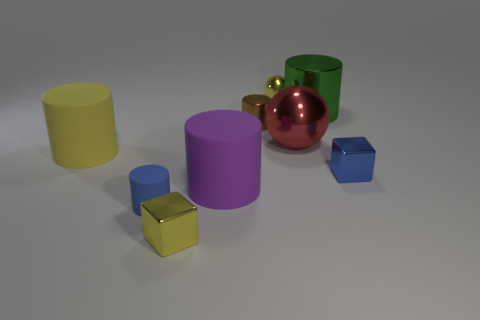Are any large green rubber cylinders visible?
Provide a succinct answer. No. Are there the same number of big purple cylinders on the right side of the big yellow rubber object and small cyan metal spheres?
Your answer should be compact. No. Is there any other thing that has the same material as the yellow block?
Your answer should be compact. Yes. How many tiny objects are either cyan metallic cubes or purple matte things?
Your answer should be very brief. 0. What is the shape of the metallic thing that is the same color as the small sphere?
Your answer should be very brief. Cube. Is the small cylinder that is in front of the large metal sphere made of the same material as the small yellow sphere?
Offer a terse response. No. The block behind the small blue thing that is to the left of the big metallic ball is made of what material?
Give a very brief answer. Metal. What number of purple things are the same shape as the red metal thing?
Make the answer very short. 0. There is a yellow metal thing behind the metallic cube that is on the right side of the shiny object in front of the small blue matte cylinder; what is its size?
Provide a short and direct response. Small. What number of yellow things are tiny blocks or rubber things?
Ensure brevity in your answer.  2. 